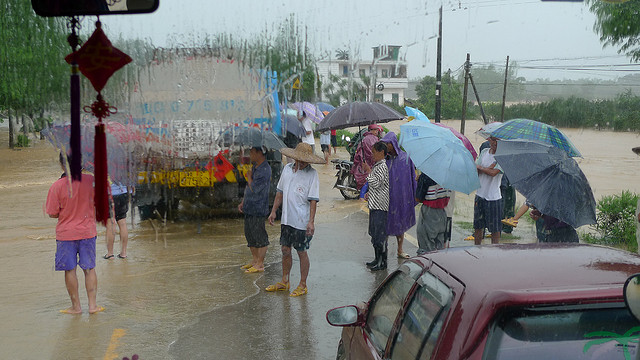<image>What is on the woman in oranges head? I am not sure what is on the woman in orange's head. It could be an umbrella, a hat, or nothing. What is the job of the person in red? It is ambiguous what is the job of the person in red. What is on the woman in oranges head? I am not sure what is on the woman in oranges head. It can be seen an umbrella, a hat or nothing. What is the job of the person in red? It is ambiguous what is the job of the person in red. It can be seen as a spectator, salesman, directing traffic, store owner, driver or homeless. 